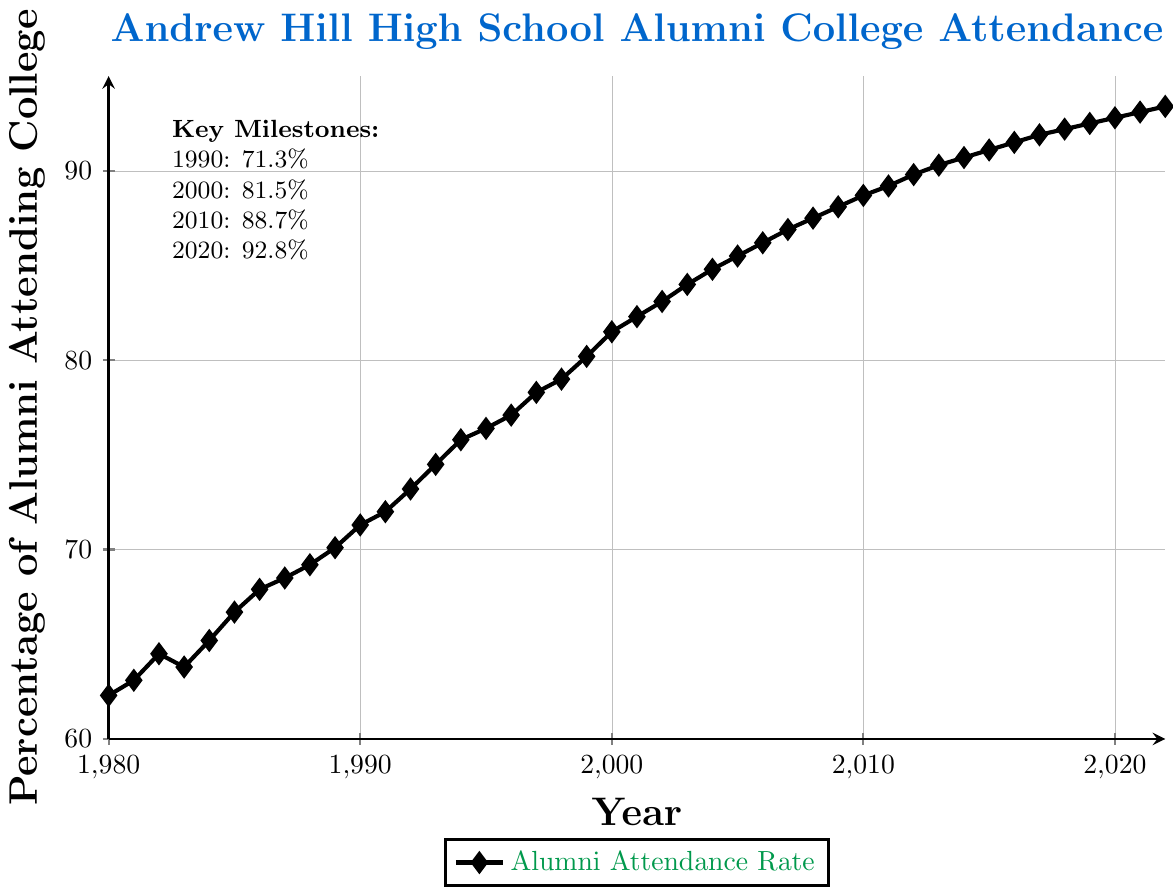What's the percentage of Andrew Hill High School alumni attending college in the year 2000? The figure indicates the attendance percentage for each year. Locate the year 2000 on the x-axis and read the corresponding percentage on the y-axis.
Answer: 81.5% Has the percentage of alumni attending college increased or decreased from 1990 to 2020? Compare the values for the years 1990 and 2020. In 1990, the percentage is 71.3%, and in 2020, it's 92.8%. Since 92.8% is greater than 71.3%, the percentage has increased.
Answer: Increased What is the difference in the percentage of alumni attending college between 1980 and 2022? Find the percentages for 1980 and 2022 from the plot. In 1980, it's 62.3%, and in 2022, it's 93.4%. Subtract the 1980 percentage from the 2022 percentage: 93.4% - 62.3% = 31.1%.
Answer: 31.1% What was the median percentage of alumni attending college between the years 1980 and 2022? To find the median percentage, list all the percentages from 1980 to 2022 and find the middle value. There are 43 values, so the median is the 22nd value: 84.0% (2003).
Answer: 84.0% Which year saw the highest percentage increase from the previous year? Calculate the year-to-year differences and identify the largest increase. 1993 to 1994 had the highest increase of 1.3% (74.5% to 75.8%).
Answer: 1993 to 1994 How many years did it take for the percentage to increase from 70% to 90%? Identify the first year the percentage reached 70%, which is 1989. Then, identify the first year it reached 90%, which is 2013. The number of years between 1989 and 2013 is 24 years.
Answer: 24 years What is the average percentage of alumni attending college from 2010 to 2022? Sum the percentages from 2010 to 2022 and divide by the number of years. There are 13 values (88.7, 89.2, 89.8, 90.3, 90.7, 91.1, 91.5, 91.9, 92.2, 92.5, 92.8, 93.1, 93.4). Total = 1185.2. Average = 1185.2 / 13 ≈ 91.2%
Answer: 91.2% What color represents the alumni attendance rate line in the plot? The color used for the line in the plot is indicated in the figure's legend as "ahgreen."
Answer: Green Is there any year where the percentage of alumni attending college stayed constant or decreased from the previous year? Analyze the plot for any flat or downward trends. From 1983 to 1984, the percentage decreased from 63.8% to 65.2%. No years had a constant rate.
Answer: No noticeable decrease 